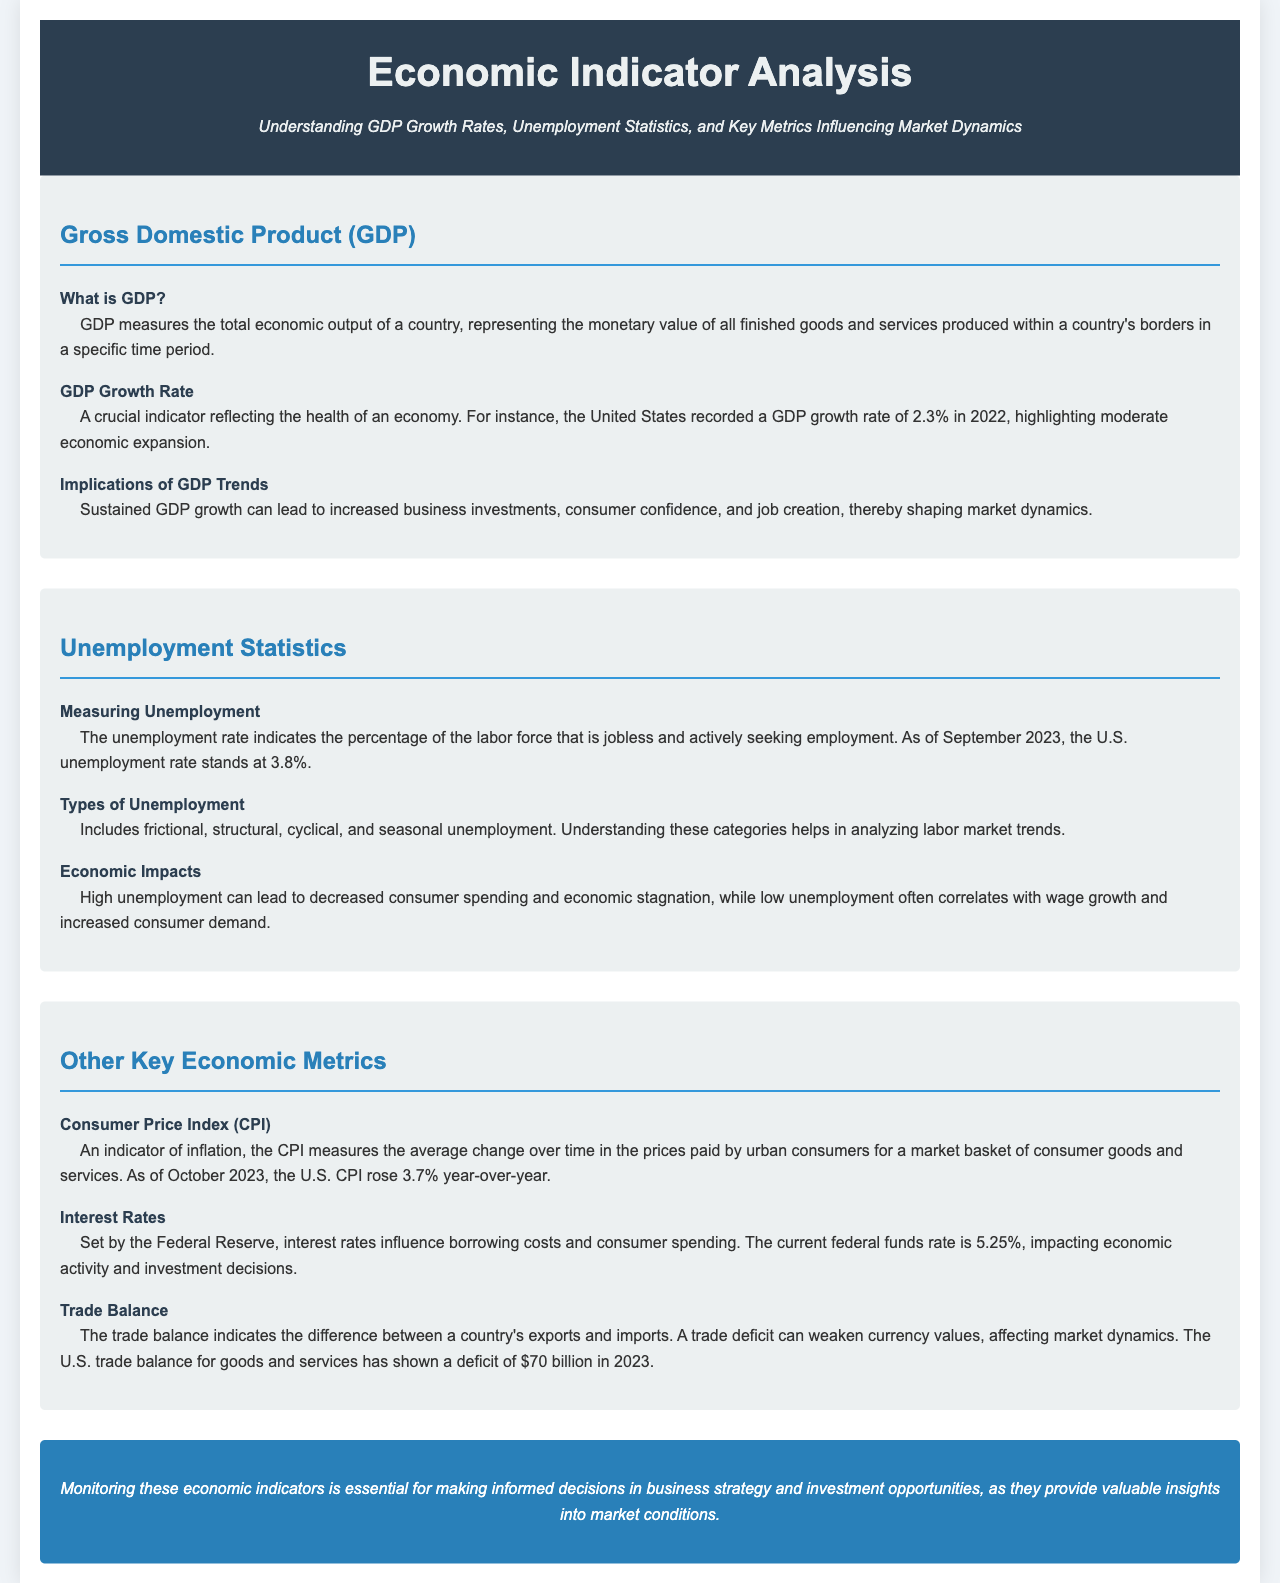What does GDP measure? GDP measures the total economic output of a country, representing the monetary value of all finished goods and services produced within a country's borders in a specific time period.
Answer: Total economic output What was the U.S. GDP growth rate in 2022? The document states that the United States recorded a GDP growth rate of 2.3% in 2022.
Answer: 2.3% What is the current U.S. unemployment rate as of September 2023? As of September 2023, the U.S. unemployment rate stands at 3.8%.
Answer: 3.8% What is the Consumer Price Index (CPI) increase as of October 2023? As of October 2023, the U.S. CPI rose 3.7% year-over-year.
Answer: 3.7% How many types of unemployment are listed in the document? The document mentions four types of unemployment: frictional, structural, cyclical, and seasonal.
Answer: Four What is the impact of high unemployment mentioned in the brochure? High unemployment can lead to decreased consumer spending and economic stagnation.
Answer: Decreased consumer spending What current federal funds rate is mentioned? The current federal funds rate is stated as 5.25%.
Answer: 5.25% What does the trade balance indicate? The trade balance indicates the difference between a country's exports and imports.
Answer: Difference between exports and imports What is the significance of monitoring economic indicators? Monitoring these economic indicators is essential for making informed decisions in business strategy and investment opportunities.
Answer: Informed decisions 